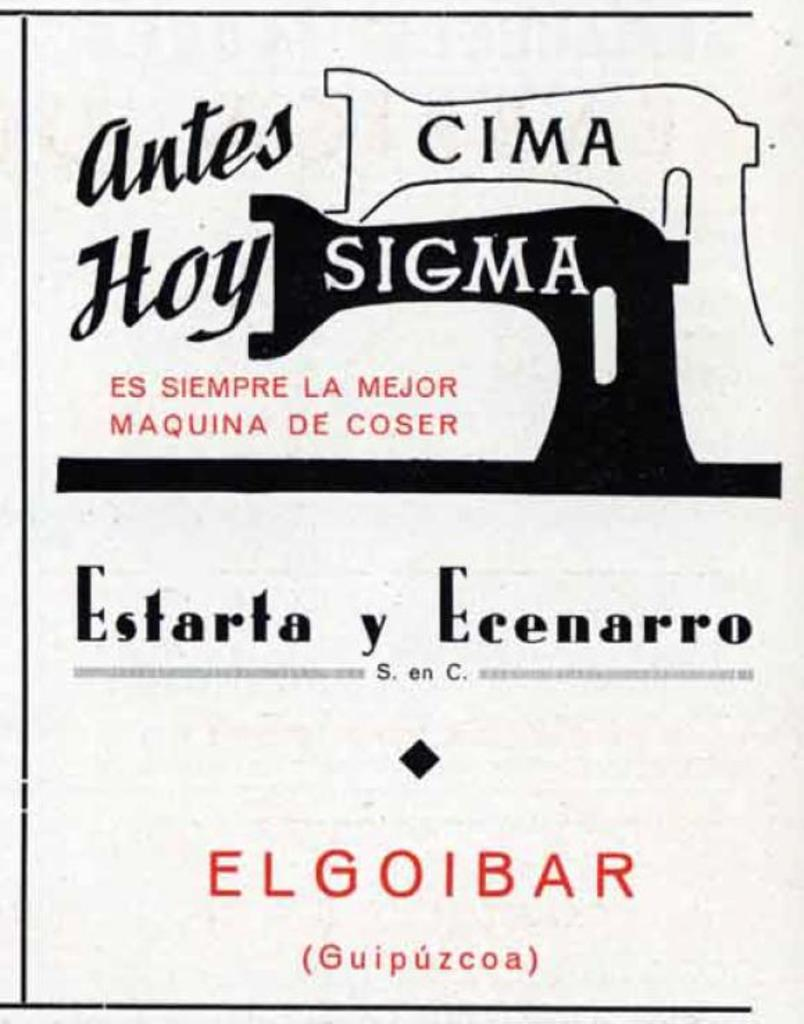<image>
Create a compact narrative representing the image presented. A poster that says Antes Cima How Sigma and Estarta y Ecenarro. 